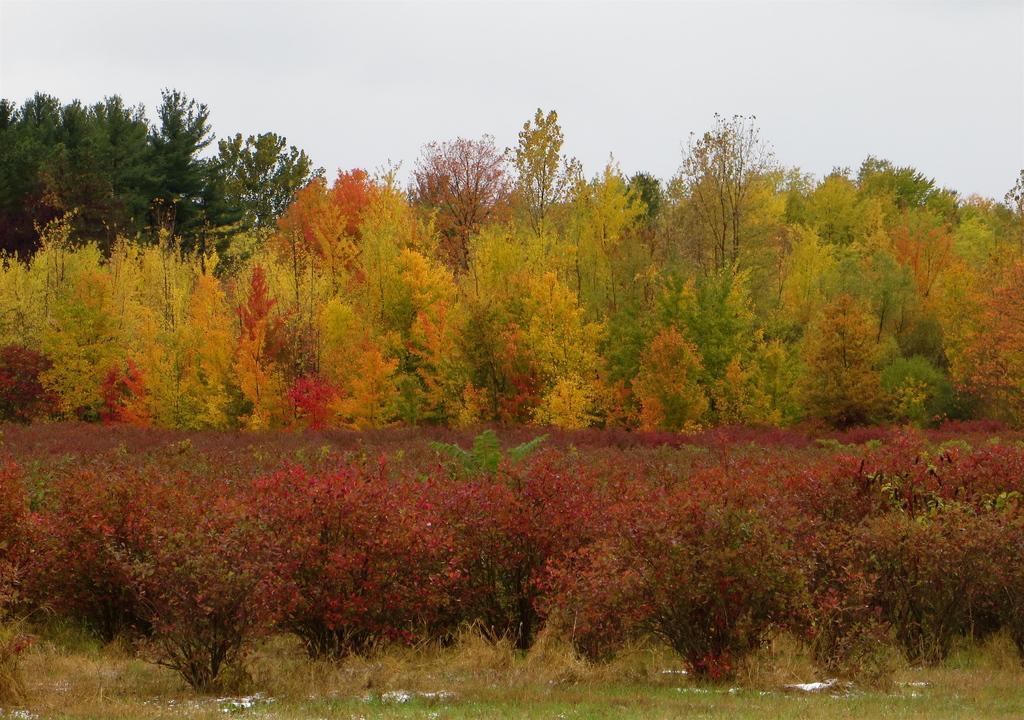In one or two sentences, can you explain what this image depicts? In this picture we can see some trees here, at the bottom there is grass, we can see the sky at the top of the picture. 